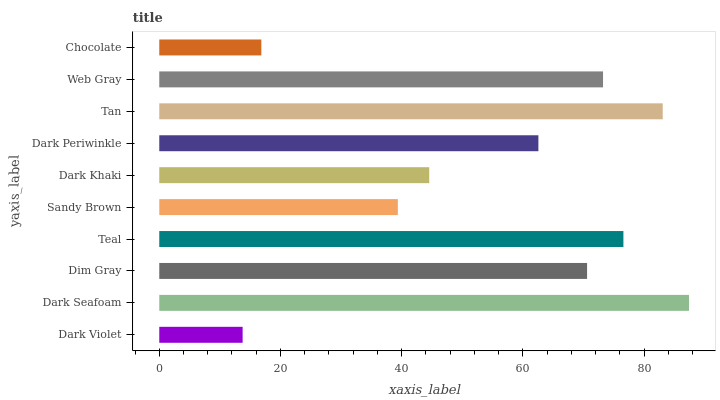Is Dark Violet the minimum?
Answer yes or no. Yes. Is Dark Seafoam the maximum?
Answer yes or no. Yes. Is Dim Gray the minimum?
Answer yes or no. No. Is Dim Gray the maximum?
Answer yes or no. No. Is Dark Seafoam greater than Dim Gray?
Answer yes or no. Yes. Is Dim Gray less than Dark Seafoam?
Answer yes or no. Yes. Is Dim Gray greater than Dark Seafoam?
Answer yes or no. No. Is Dark Seafoam less than Dim Gray?
Answer yes or no. No. Is Dim Gray the high median?
Answer yes or no. Yes. Is Dark Periwinkle the low median?
Answer yes or no. Yes. Is Dark Periwinkle the high median?
Answer yes or no. No. Is Dark Khaki the low median?
Answer yes or no. No. 